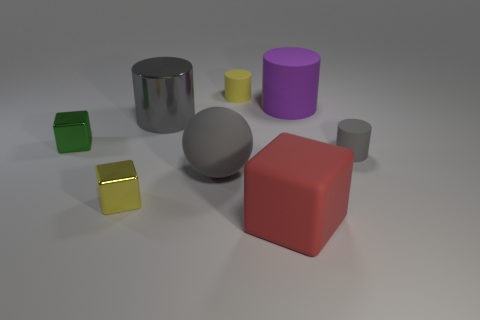Which objects in the image appear to have a metallic texture? The cylindrical object and the small cube closest to the front of the picture appear to have a metallic texture, with shiny reflective surfaces that distinguish them from the other objects. 